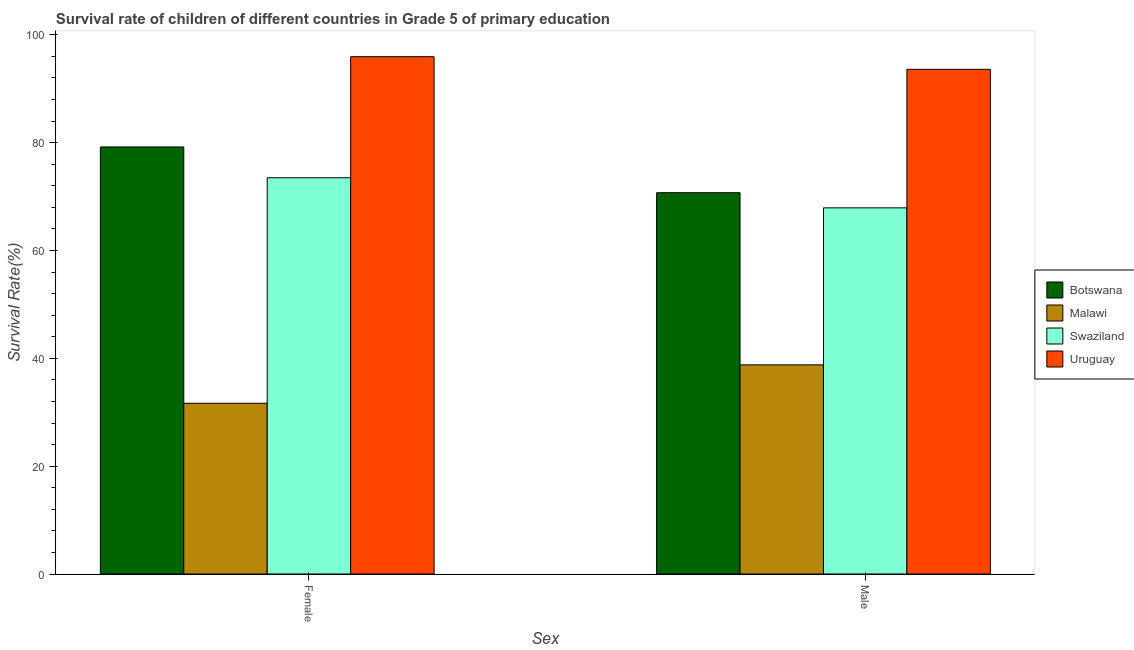How many groups of bars are there?
Keep it short and to the point. 2. Are the number of bars per tick equal to the number of legend labels?
Provide a short and direct response. Yes. What is the survival rate of male students in primary education in Uruguay?
Provide a succinct answer. 93.58. Across all countries, what is the maximum survival rate of female students in primary education?
Provide a succinct answer. 95.93. Across all countries, what is the minimum survival rate of male students in primary education?
Give a very brief answer. 38.78. In which country was the survival rate of male students in primary education maximum?
Offer a terse response. Uruguay. In which country was the survival rate of male students in primary education minimum?
Your answer should be very brief. Malawi. What is the total survival rate of male students in primary education in the graph?
Keep it short and to the point. 270.97. What is the difference between the survival rate of male students in primary education in Swaziland and that in Botswana?
Your response must be concise. -2.81. What is the difference between the survival rate of male students in primary education in Botswana and the survival rate of female students in primary education in Swaziland?
Give a very brief answer. -2.77. What is the average survival rate of female students in primary education per country?
Offer a very short reply. 70.06. What is the difference between the survival rate of female students in primary education and survival rate of male students in primary education in Malawi?
Make the answer very short. -7.12. In how many countries, is the survival rate of female students in primary education greater than 36 %?
Keep it short and to the point. 3. What is the ratio of the survival rate of female students in primary education in Uruguay to that in Malawi?
Your response must be concise. 3.03. What does the 3rd bar from the left in Female represents?
Give a very brief answer. Swaziland. What does the 1st bar from the right in Female represents?
Give a very brief answer. Uruguay. How many bars are there?
Provide a short and direct response. 8. What is the difference between two consecutive major ticks on the Y-axis?
Make the answer very short. 20. Does the graph contain any zero values?
Give a very brief answer. No. Does the graph contain grids?
Make the answer very short. No. What is the title of the graph?
Your answer should be compact. Survival rate of children of different countries in Grade 5 of primary education. Does "Palau" appear as one of the legend labels in the graph?
Your answer should be very brief. No. What is the label or title of the X-axis?
Your response must be concise. Sex. What is the label or title of the Y-axis?
Make the answer very short. Survival Rate(%). What is the Survival Rate(%) in Botswana in Female?
Offer a terse response. 79.19. What is the Survival Rate(%) in Malawi in Female?
Provide a succinct answer. 31.66. What is the Survival Rate(%) in Swaziland in Female?
Ensure brevity in your answer.  73.48. What is the Survival Rate(%) of Uruguay in Female?
Provide a short and direct response. 95.93. What is the Survival Rate(%) of Botswana in Male?
Give a very brief answer. 70.71. What is the Survival Rate(%) of Malawi in Male?
Your answer should be compact. 38.78. What is the Survival Rate(%) in Swaziland in Male?
Make the answer very short. 67.9. What is the Survival Rate(%) of Uruguay in Male?
Provide a short and direct response. 93.58. Across all Sex, what is the maximum Survival Rate(%) of Botswana?
Offer a very short reply. 79.19. Across all Sex, what is the maximum Survival Rate(%) in Malawi?
Keep it short and to the point. 38.78. Across all Sex, what is the maximum Survival Rate(%) in Swaziland?
Provide a short and direct response. 73.48. Across all Sex, what is the maximum Survival Rate(%) in Uruguay?
Your answer should be compact. 95.93. Across all Sex, what is the minimum Survival Rate(%) of Botswana?
Provide a short and direct response. 70.71. Across all Sex, what is the minimum Survival Rate(%) of Malawi?
Keep it short and to the point. 31.66. Across all Sex, what is the minimum Survival Rate(%) in Swaziland?
Give a very brief answer. 67.9. Across all Sex, what is the minimum Survival Rate(%) of Uruguay?
Ensure brevity in your answer.  93.58. What is the total Survival Rate(%) of Botswana in the graph?
Your answer should be compact. 149.9. What is the total Survival Rate(%) of Malawi in the graph?
Offer a terse response. 70.44. What is the total Survival Rate(%) in Swaziland in the graph?
Make the answer very short. 141.38. What is the total Survival Rate(%) in Uruguay in the graph?
Your response must be concise. 189.51. What is the difference between the Survival Rate(%) in Botswana in Female and that in Male?
Your answer should be compact. 8.48. What is the difference between the Survival Rate(%) of Malawi in Female and that in Male?
Provide a succinct answer. -7.12. What is the difference between the Survival Rate(%) in Swaziland in Female and that in Male?
Offer a very short reply. 5.58. What is the difference between the Survival Rate(%) in Uruguay in Female and that in Male?
Keep it short and to the point. 2.34. What is the difference between the Survival Rate(%) in Botswana in Female and the Survival Rate(%) in Malawi in Male?
Ensure brevity in your answer.  40.41. What is the difference between the Survival Rate(%) in Botswana in Female and the Survival Rate(%) in Swaziland in Male?
Offer a terse response. 11.29. What is the difference between the Survival Rate(%) in Botswana in Female and the Survival Rate(%) in Uruguay in Male?
Your response must be concise. -14.39. What is the difference between the Survival Rate(%) in Malawi in Female and the Survival Rate(%) in Swaziland in Male?
Keep it short and to the point. -36.24. What is the difference between the Survival Rate(%) in Malawi in Female and the Survival Rate(%) in Uruguay in Male?
Your response must be concise. -61.93. What is the difference between the Survival Rate(%) in Swaziland in Female and the Survival Rate(%) in Uruguay in Male?
Offer a very short reply. -20.1. What is the average Survival Rate(%) of Botswana per Sex?
Give a very brief answer. 74.95. What is the average Survival Rate(%) of Malawi per Sex?
Ensure brevity in your answer.  35.22. What is the average Survival Rate(%) in Swaziland per Sex?
Provide a short and direct response. 70.69. What is the average Survival Rate(%) of Uruguay per Sex?
Offer a very short reply. 94.76. What is the difference between the Survival Rate(%) of Botswana and Survival Rate(%) of Malawi in Female?
Keep it short and to the point. 47.53. What is the difference between the Survival Rate(%) of Botswana and Survival Rate(%) of Swaziland in Female?
Keep it short and to the point. 5.71. What is the difference between the Survival Rate(%) in Botswana and Survival Rate(%) in Uruguay in Female?
Offer a very short reply. -16.74. What is the difference between the Survival Rate(%) of Malawi and Survival Rate(%) of Swaziland in Female?
Offer a terse response. -41.82. What is the difference between the Survival Rate(%) of Malawi and Survival Rate(%) of Uruguay in Female?
Make the answer very short. -64.27. What is the difference between the Survival Rate(%) of Swaziland and Survival Rate(%) of Uruguay in Female?
Make the answer very short. -22.45. What is the difference between the Survival Rate(%) of Botswana and Survival Rate(%) of Malawi in Male?
Keep it short and to the point. 31.93. What is the difference between the Survival Rate(%) in Botswana and Survival Rate(%) in Swaziland in Male?
Your answer should be very brief. 2.81. What is the difference between the Survival Rate(%) of Botswana and Survival Rate(%) of Uruguay in Male?
Provide a succinct answer. -22.88. What is the difference between the Survival Rate(%) of Malawi and Survival Rate(%) of Swaziland in Male?
Your response must be concise. -29.12. What is the difference between the Survival Rate(%) in Malawi and Survival Rate(%) in Uruguay in Male?
Provide a short and direct response. -54.81. What is the difference between the Survival Rate(%) in Swaziland and Survival Rate(%) in Uruguay in Male?
Make the answer very short. -25.69. What is the ratio of the Survival Rate(%) in Botswana in Female to that in Male?
Offer a terse response. 1.12. What is the ratio of the Survival Rate(%) of Malawi in Female to that in Male?
Offer a very short reply. 0.82. What is the ratio of the Survival Rate(%) in Swaziland in Female to that in Male?
Make the answer very short. 1.08. What is the ratio of the Survival Rate(%) in Uruguay in Female to that in Male?
Provide a succinct answer. 1.02. What is the difference between the highest and the second highest Survival Rate(%) of Botswana?
Offer a terse response. 8.48. What is the difference between the highest and the second highest Survival Rate(%) of Malawi?
Your answer should be very brief. 7.12. What is the difference between the highest and the second highest Survival Rate(%) of Swaziland?
Make the answer very short. 5.58. What is the difference between the highest and the second highest Survival Rate(%) of Uruguay?
Keep it short and to the point. 2.34. What is the difference between the highest and the lowest Survival Rate(%) of Botswana?
Provide a short and direct response. 8.48. What is the difference between the highest and the lowest Survival Rate(%) in Malawi?
Offer a terse response. 7.12. What is the difference between the highest and the lowest Survival Rate(%) of Swaziland?
Provide a succinct answer. 5.58. What is the difference between the highest and the lowest Survival Rate(%) in Uruguay?
Provide a succinct answer. 2.34. 